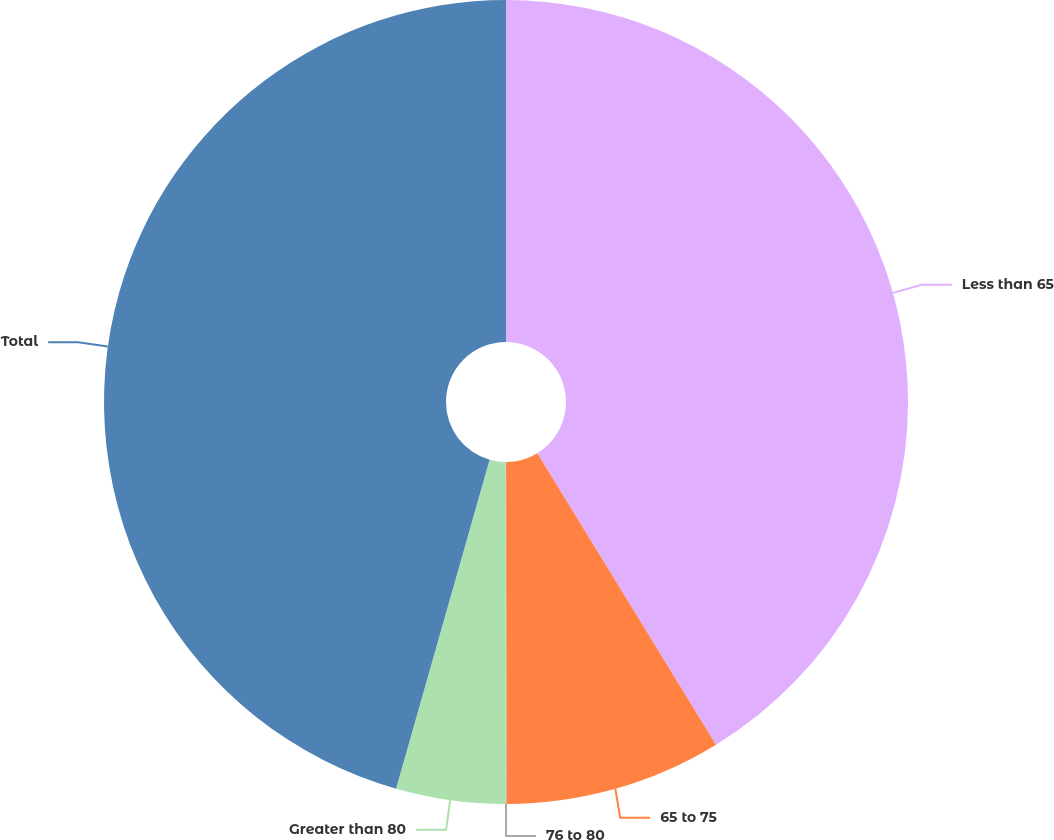Convert chart to OTSL. <chart><loc_0><loc_0><loc_500><loc_500><pie_chart><fcel>Less than 65<fcel>65 to 75<fcel>76 to 80<fcel>Greater than 80<fcel>Total<nl><fcel>41.25%<fcel>8.73%<fcel>0.04%<fcel>4.39%<fcel>45.59%<nl></chart> 